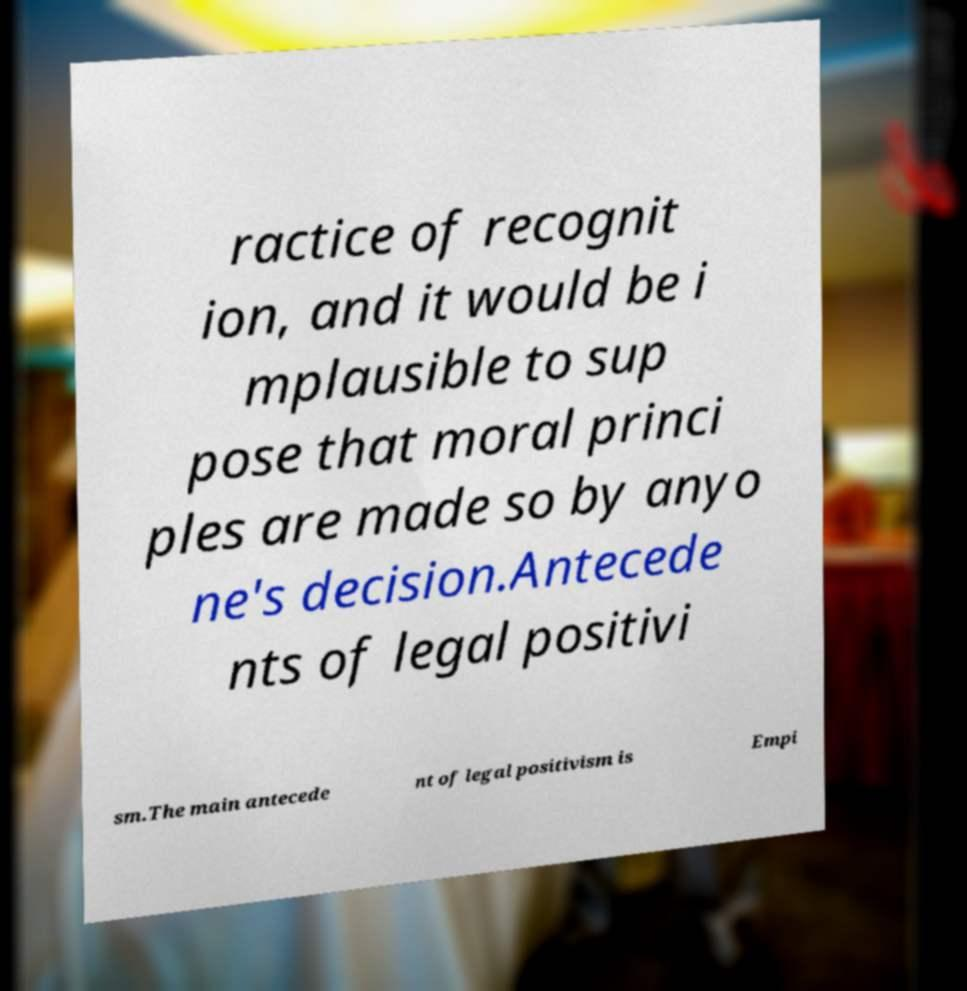For documentation purposes, I need the text within this image transcribed. Could you provide that? ractice of recognit ion, and it would be i mplausible to sup pose that moral princi ples are made so by anyo ne's decision.Antecede nts of legal positivi sm.The main antecede nt of legal positivism is Empi 